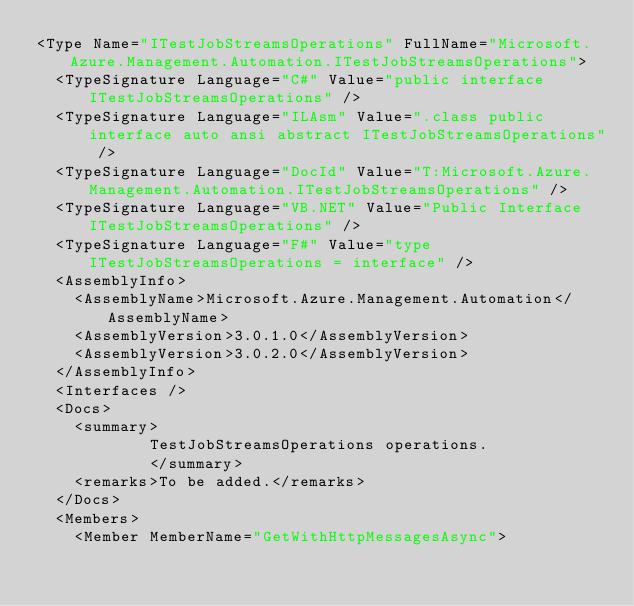Convert code to text. <code><loc_0><loc_0><loc_500><loc_500><_XML_><Type Name="ITestJobStreamsOperations" FullName="Microsoft.Azure.Management.Automation.ITestJobStreamsOperations">
  <TypeSignature Language="C#" Value="public interface ITestJobStreamsOperations" />
  <TypeSignature Language="ILAsm" Value=".class public interface auto ansi abstract ITestJobStreamsOperations" />
  <TypeSignature Language="DocId" Value="T:Microsoft.Azure.Management.Automation.ITestJobStreamsOperations" />
  <TypeSignature Language="VB.NET" Value="Public Interface ITestJobStreamsOperations" />
  <TypeSignature Language="F#" Value="type ITestJobStreamsOperations = interface" />
  <AssemblyInfo>
    <AssemblyName>Microsoft.Azure.Management.Automation</AssemblyName>
    <AssemblyVersion>3.0.1.0</AssemblyVersion>
    <AssemblyVersion>3.0.2.0</AssemblyVersion>
  </AssemblyInfo>
  <Interfaces />
  <Docs>
    <summary>
            TestJobStreamsOperations operations.
            </summary>
    <remarks>To be added.</remarks>
  </Docs>
  <Members>
    <Member MemberName="GetWithHttpMessagesAsync"></code> 